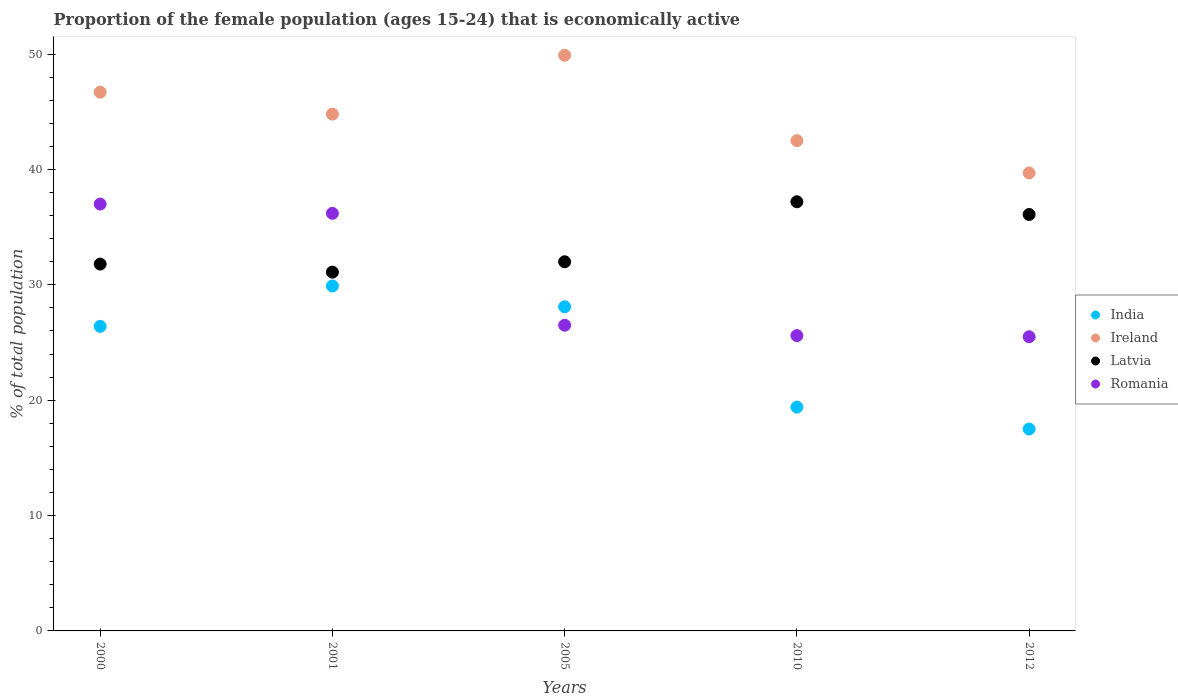How many different coloured dotlines are there?
Give a very brief answer. 4. Is the number of dotlines equal to the number of legend labels?
Keep it short and to the point. Yes. What is the proportion of the female population that is economically active in Latvia in 2012?
Ensure brevity in your answer.  36.1. Across all years, what is the maximum proportion of the female population that is economically active in Latvia?
Your answer should be compact. 37.2. In which year was the proportion of the female population that is economically active in Ireland maximum?
Offer a very short reply. 2005. In which year was the proportion of the female population that is economically active in Latvia minimum?
Keep it short and to the point. 2001. What is the total proportion of the female population that is economically active in Ireland in the graph?
Ensure brevity in your answer.  223.6. What is the difference between the proportion of the female population that is economically active in India in 2000 and that in 2012?
Your answer should be compact. 8.9. What is the difference between the proportion of the female population that is economically active in Latvia in 2000 and the proportion of the female population that is economically active in Romania in 2010?
Your answer should be compact. 6.2. What is the average proportion of the female population that is economically active in India per year?
Make the answer very short. 24.26. In the year 2001, what is the difference between the proportion of the female population that is economically active in Romania and proportion of the female population that is economically active in Ireland?
Give a very brief answer. -8.6. What is the ratio of the proportion of the female population that is economically active in Romania in 2001 to that in 2005?
Offer a very short reply. 1.37. Is the proportion of the female population that is economically active in India in 2000 less than that in 2005?
Give a very brief answer. Yes. What is the difference between the highest and the second highest proportion of the female population that is economically active in India?
Make the answer very short. 1.8. What is the difference between the highest and the lowest proportion of the female population that is economically active in Latvia?
Your answer should be very brief. 6.1. In how many years, is the proportion of the female population that is economically active in Romania greater than the average proportion of the female population that is economically active in Romania taken over all years?
Offer a terse response. 2. Is the proportion of the female population that is economically active in Ireland strictly greater than the proportion of the female population that is economically active in Latvia over the years?
Keep it short and to the point. Yes. Is the proportion of the female population that is economically active in Ireland strictly less than the proportion of the female population that is economically active in Latvia over the years?
Ensure brevity in your answer.  No. How many dotlines are there?
Keep it short and to the point. 4. How many years are there in the graph?
Your answer should be very brief. 5. Does the graph contain grids?
Your response must be concise. No. Where does the legend appear in the graph?
Offer a very short reply. Center right. How are the legend labels stacked?
Offer a terse response. Vertical. What is the title of the graph?
Keep it short and to the point. Proportion of the female population (ages 15-24) that is economically active. What is the label or title of the X-axis?
Keep it short and to the point. Years. What is the label or title of the Y-axis?
Make the answer very short. % of total population. What is the % of total population of India in 2000?
Your answer should be very brief. 26.4. What is the % of total population in Ireland in 2000?
Your response must be concise. 46.7. What is the % of total population of Latvia in 2000?
Keep it short and to the point. 31.8. What is the % of total population of Romania in 2000?
Ensure brevity in your answer.  37. What is the % of total population of India in 2001?
Offer a terse response. 29.9. What is the % of total population in Ireland in 2001?
Make the answer very short. 44.8. What is the % of total population in Latvia in 2001?
Provide a succinct answer. 31.1. What is the % of total population in Romania in 2001?
Provide a succinct answer. 36.2. What is the % of total population in India in 2005?
Your answer should be compact. 28.1. What is the % of total population in Ireland in 2005?
Provide a short and direct response. 49.9. What is the % of total population of Latvia in 2005?
Provide a short and direct response. 32. What is the % of total population in Romania in 2005?
Give a very brief answer. 26.5. What is the % of total population in India in 2010?
Provide a succinct answer. 19.4. What is the % of total population of Ireland in 2010?
Offer a very short reply. 42.5. What is the % of total population of Latvia in 2010?
Your answer should be very brief. 37.2. What is the % of total population of Romania in 2010?
Provide a short and direct response. 25.6. What is the % of total population in Ireland in 2012?
Provide a short and direct response. 39.7. What is the % of total population of Latvia in 2012?
Provide a succinct answer. 36.1. What is the % of total population in Romania in 2012?
Ensure brevity in your answer.  25.5. Across all years, what is the maximum % of total population of India?
Your response must be concise. 29.9. Across all years, what is the maximum % of total population of Ireland?
Provide a succinct answer. 49.9. Across all years, what is the maximum % of total population in Latvia?
Your response must be concise. 37.2. Across all years, what is the minimum % of total population of India?
Offer a very short reply. 17.5. Across all years, what is the minimum % of total population in Ireland?
Provide a succinct answer. 39.7. Across all years, what is the minimum % of total population in Latvia?
Provide a succinct answer. 31.1. Across all years, what is the minimum % of total population in Romania?
Give a very brief answer. 25.5. What is the total % of total population in India in the graph?
Offer a terse response. 121.3. What is the total % of total population of Ireland in the graph?
Provide a short and direct response. 223.6. What is the total % of total population of Latvia in the graph?
Your response must be concise. 168.2. What is the total % of total population of Romania in the graph?
Your answer should be very brief. 150.8. What is the difference between the % of total population in India in 2000 and that in 2005?
Your answer should be very brief. -1.7. What is the difference between the % of total population of Latvia in 2000 and that in 2005?
Provide a succinct answer. -0.2. What is the difference between the % of total population in Romania in 2000 and that in 2005?
Provide a short and direct response. 10.5. What is the difference between the % of total population in Latvia in 2000 and that in 2010?
Ensure brevity in your answer.  -5.4. What is the difference between the % of total population of Latvia in 2000 and that in 2012?
Provide a succinct answer. -4.3. What is the difference between the % of total population in Romania in 2001 and that in 2005?
Provide a succinct answer. 9.7. What is the difference between the % of total population in India in 2001 and that in 2010?
Ensure brevity in your answer.  10.5. What is the difference between the % of total population of Latvia in 2001 and that in 2010?
Your answer should be compact. -6.1. What is the difference between the % of total population in Romania in 2001 and that in 2010?
Ensure brevity in your answer.  10.6. What is the difference between the % of total population of India in 2001 and that in 2012?
Ensure brevity in your answer.  12.4. What is the difference between the % of total population of Latvia in 2001 and that in 2012?
Your answer should be very brief. -5. What is the difference between the % of total population in Romania in 2001 and that in 2012?
Ensure brevity in your answer.  10.7. What is the difference between the % of total population in India in 2005 and that in 2010?
Offer a very short reply. 8.7. What is the difference between the % of total population of Ireland in 2005 and that in 2010?
Ensure brevity in your answer.  7.4. What is the difference between the % of total population in Latvia in 2005 and that in 2010?
Give a very brief answer. -5.2. What is the difference between the % of total population in Romania in 2005 and that in 2010?
Provide a succinct answer. 0.9. What is the difference between the % of total population of Ireland in 2005 and that in 2012?
Ensure brevity in your answer.  10.2. What is the difference between the % of total population in Latvia in 2005 and that in 2012?
Your answer should be very brief. -4.1. What is the difference between the % of total population in India in 2010 and that in 2012?
Keep it short and to the point. 1.9. What is the difference between the % of total population of Ireland in 2010 and that in 2012?
Your answer should be compact. 2.8. What is the difference between the % of total population in Romania in 2010 and that in 2012?
Keep it short and to the point. 0.1. What is the difference between the % of total population in India in 2000 and the % of total population in Ireland in 2001?
Your response must be concise. -18.4. What is the difference between the % of total population of India in 2000 and the % of total population of Latvia in 2001?
Make the answer very short. -4.7. What is the difference between the % of total population in India in 2000 and the % of total population in Romania in 2001?
Offer a very short reply. -9.8. What is the difference between the % of total population of Ireland in 2000 and the % of total population of Latvia in 2001?
Keep it short and to the point. 15.6. What is the difference between the % of total population in India in 2000 and the % of total population in Ireland in 2005?
Your answer should be very brief. -23.5. What is the difference between the % of total population of Ireland in 2000 and the % of total population of Romania in 2005?
Your answer should be very brief. 20.2. What is the difference between the % of total population in Latvia in 2000 and the % of total population in Romania in 2005?
Provide a succinct answer. 5.3. What is the difference between the % of total population of India in 2000 and the % of total population of Ireland in 2010?
Offer a very short reply. -16.1. What is the difference between the % of total population in India in 2000 and the % of total population in Romania in 2010?
Your answer should be very brief. 0.8. What is the difference between the % of total population in Ireland in 2000 and the % of total population in Romania in 2010?
Give a very brief answer. 21.1. What is the difference between the % of total population in Latvia in 2000 and the % of total population in Romania in 2010?
Offer a very short reply. 6.2. What is the difference between the % of total population of India in 2000 and the % of total population of Latvia in 2012?
Provide a short and direct response. -9.7. What is the difference between the % of total population of Ireland in 2000 and the % of total population of Romania in 2012?
Give a very brief answer. 21.2. What is the difference between the % of total population of Latvia in 2000 and the % of total population of Romania in 2012?
Offer a terse response. 6.3. What is the difference between the % of total population in India in 2001 and the % of total population in Latvia in 2005?
Provide a succinct answer. -2.1. What is the difference between the % of total population in India in 2001 and the % of total population in Romania in 2005?
Your answer should be compact. 3.4. What is the difference between the % of total population of Ireland in 2001 and the % of total population of Latvia in 2005?
Give a very brief answer. 12.8. What is the difference between the % of total population in India in 2001 and the % of total population in Ireland in 2010?
Offer a terse response. -12.6. What is the difference between the % of total population of India in 2001 and the % of total population of Ireland in 2012?
Keep it short and to the point. -9.8. What is the difference between the % of total population in Ireland in 2001 and the % of total population in Latvia in 2012?
Your answer should be very brief. 8.7. What is the difference between the % of total population of Ireland in 2001 and the % of total population of Romania in 2012?
Offer a terse response. 19.3. What is the difference between the % of total population in India in 2005 and the % of total population in Ireland in 2010?
Offer a terse response. -14.4. What is the difference between the % of total population of India in 2005 and the % of total population of Latvia in 2010?
Offer a very short reply. -9.1. What is the difference between the % of total population of Ireland in 2005 and the % of total population of Latvia in 2010?
Make the answer very short. 12.7. What is the difference between the % of total population of Ireland in 2005 and the % of total population of Romania in 2010?
Your answer should be compact. 24.3. What is the difference between the % of total population of Latvia in 2005 and the % of total population of Romania in 2010?
Your response must be concise. 6.4. What is the difference between the % of total population in India in 2005 and the % of total population in Latvia in 2012?
Your answer should be very brief. -8. What is the difference between the % of total population of India in 2005 and the % of total population of Romania in 2012?
Keep it short and to the point. 2.6. What is the difference between the % of total population of Ireland in 2005 and the % of total population of Romania in 2012?
Offer a terse response. 24.4. What is the difference between the % of total population in Latvia in 2005 and the % of total population in Romania in 2012?
Your answer should be very brief. 6.5. What is the difference between the % of total population of India in 2010 and the % of total population of Ireland in 2012?
Your answer should be compact. -20.3. What is the difference between the % of total population of India in 2010 and the % of total population of Latvia in 2012?
Make the answer very short. -16.7. What is the difference between the % of total population in Ireland in 2010 and the % of total population in Latvia in 2012?
Provide a short and direct response. 6.4. What is the difference between the % of total population of Latvia in 2010 and the % of total population of Romania in 2012?
Your answer should be compact. 11.7. What is the average % of total population of India per year?
Provide a succinct answer. 24.26. What is the average % of total population in Ireland per year?
Give a very brief answer. 44.72. What is the average % of total population in Latvia per year?
Provide a succinct answer. 33.64. What is the average % of total population of Romania per year?
Provide a succinct answer. 30.16. In the year 2000, what is the difference between the % of total population in India and % of total population in Ireland?
Your response must be concise. -20.3. In the year 2000, what is the difference between the % of total population of Ireland and % of total population of Latvia?
Give a very brief answer. 14.9. In the year 2001, what is the difference between the % of total population in India and % of total population in Ireland?
Make the answer very short. -14.9. In the year 2001, what is the difference between the % of total population of India and % of total population of Latvia?
Keep it short and to the point. -1.2. In the year 2001, what is the difference between the % of total population in Ireland and % of total population in Romania?
Make the answer very short. 8.6. In the year 2005, what is the difference between the % of total population of India and % of total population of Ireland?
Provide a short and direct response. -21.8. In the year 2005, what is the difference between the % of total population in Ireland and % of total population in Latvia?
Provide a short and direct response. 17.9. In the year 2005, what is the difference between the % of total population of Ireland and % of total population of Romania?
Keep it short and to the point. 23.4. In the year 2005, what is the difference between the % of total population of Latvia and % of total population of Romania?
Offer a terse response. 5.5. In the year 2010, what is the difference between the % of total population in India and % of total population in Ireland?
Provide a short and direct response. -23.1. In the year 2010, what is the difference between the % of total population in India and % of total population in Latvia?
Keep it short and to the point. -17.8. In the year 2010, what is the difference between the % of total population in India and % of total population in Romania?
Offer a terse response. -6.2. In the year 2010, what is the difference between the % of total population in Ireland and % of total population in Latvia?
Provide a succinct answer. 5.3. In the year 2010, what is the difference between the % of total population in Latvia and % of total population in Romania?
Your response must be concise. 11.6. In the year 2012, what is the difference between the % of total population in India and % of total population in Ireland?
Keep it short and to the point. -22.2. In the year 2012, what is the difference between the % of total population of India and % of total population of Latvia?
Provide a succinct answer. -18.6. In the year 2012, what is the difference between the % of total population in India and % of total population in Romania?
Provide a short and direct response. -8. In the year 2012, what is the difference between the % of total population in Ireland and % of total population in Latvia?
Make the answer very short. 3.6. What is the ratio of the % of total population of India in 2000 to that in 2001?
Offer a very short reply. 0.88. What is the ratio of the % of total population in Ireland in 2000 to that in 2001?
Provide a short and direct response. 1.04. What is the ratio of the % of total population in Latvia in 2000 to that in 2001?
Offer a terse response. 1.02. What is the ratio of the % of total population in Romania in 2000 to that in 2001?
Make the answer very short. 1.02. What is the ratio of the % of total population in India in 2000 to that in 2005?
Ensure brevity in your answer.  0.94. What is the ratio of the % of total population in Ireland in 2000 to that in 2005?
Provide a succinct answer. 0.94. What is the ratio of the % of total population of Romania in 2000 to that in 2005?
Provide a succinct answer. 1.4. What is the ratio of the % of total population in India in 2000 to that in 2010?
Your response must be concise. 1.36. What is the ratio of the % of total population of Ireland in 2000 to that in 2010?
Your answer should be compact. 1.1. What is the ratio of the % of total population in Latvia in 2000 to that in 2010?
Keep it short and to the point. 0.85. What is the ratio of the % of total population of Romania in 2000 to that in 2010?
Give a very brief answer. 1.45. What is the ratio of the % of total population of India in 2000 to that in 2012?
Offer a terse response. 1.51. What is the ratio of the % of total population of Ireland in 2000 to that in 2012?
Offer a very short reply. 1.18. What is the ratio of the % of total population of Latvia in 2000 to that in 2012?
Provide a succinct answer. 0.88. What is the ratio of the % of total population in Romania in 2000 to that in 2012?
Offer a terse response. 1.45. What is the ratio of the % of total population of India in 2001 to that in 2005?
Make the answer very short. 1.06. What is the ratio of the % of total population of Ireland in 2001 to that in 2005?
Provide a short and direct response. 0.9. What is the ratio of the % of total population in Latvia in 2001 to that in 2005?
Give a very brief answer. 0.97. What is the ratio of the % of total population of Romania in 2001 to that in 2005?
Offer a terse response. 1.37. What is the ratio of the % of total population of India in 2001 to that in 2010?
Make the answer very short. 1.54. What is the ratio of the % of total population of Ireland in 2001 to that in 2010?
Your answer should be compact. 1.05. What is the ratio of the % of total population in Latvia in 2001 to that in 2010?
Make the answer very short. 0.84. What is the ratio of the % of total population in Romania in 2001 to that in 2010?
Ensure brevity in your answer.  1.41. What is the ratio of the % of total population in India in 2001 to that in 2012?
Your response must be concise. 1.71. What is the ratio of the % of total population in Ireland in 2001 to that in 2012?
Your answer should be very brief. 1.13. What is the ratio of the % of total population in Latvia in 2001 to that in 2012?
Your response must be concise. 0.86. What is the ratio of the % of total population in Romania in 2001 to that in 2012?
Give a very brief answer. 1.42. What is the ratio of the % of total population in India in 2005 to that in 2010?
Your answer should be very brief. 1.45. What is the ratio of the % of total population of Ireland in 2005 to that in 2010?
Keep it short and to the point. 1.17. What is the ratio of the % of total population in Latvia in 2005 to that in 2010?
Keep it short and to the point. 0.86. What is the ratio of the % of total population in Romania in 2005 to that in 2010?
Provide a short and direct response. 1.04. What is the ratio of the % of total population of India in 2005 to that in 2012?
Provide a short and direct response. 1.61. What is the ratio of the % of total population of Ireland in 2005 to that in 2012?
Make the answer very short. 1.26. What is the ratio of the % of total population of Latvia in 2005 to that in 2012?
Provide a short and direct response. 0.89. What is the ratio of the % of total population in Romania in 2005 to that in 2012?
Your answer should be compact. 1.04. What is the ratio of the % of total population in India in 2010 to that in 2012?
Provide a short and direct response. 1.11. What is the ratio of the % of total population of Ireland in 2010 to that in 2012?
Ensure brevity in your answer.  1.07. What is the ratio of the % of total population in Latvia in 2010 to that in 2012?
Your response must be concise. 1.03. What is the ratio of the % of total population of Romania in 2010 to that in 2012?
Your answer should be compact. 1. What is the difference between the highest and the second highest % of total population of Ireland?
Your answer should be very brief. 3.2. What is the difference between the highest and the second highest % of total population of Romania?
Give a very brief answer. 0.8. What is the difference between the highest and the lowest % of total population in Latvia?
Ensure brevity in your answer.  6.1. 